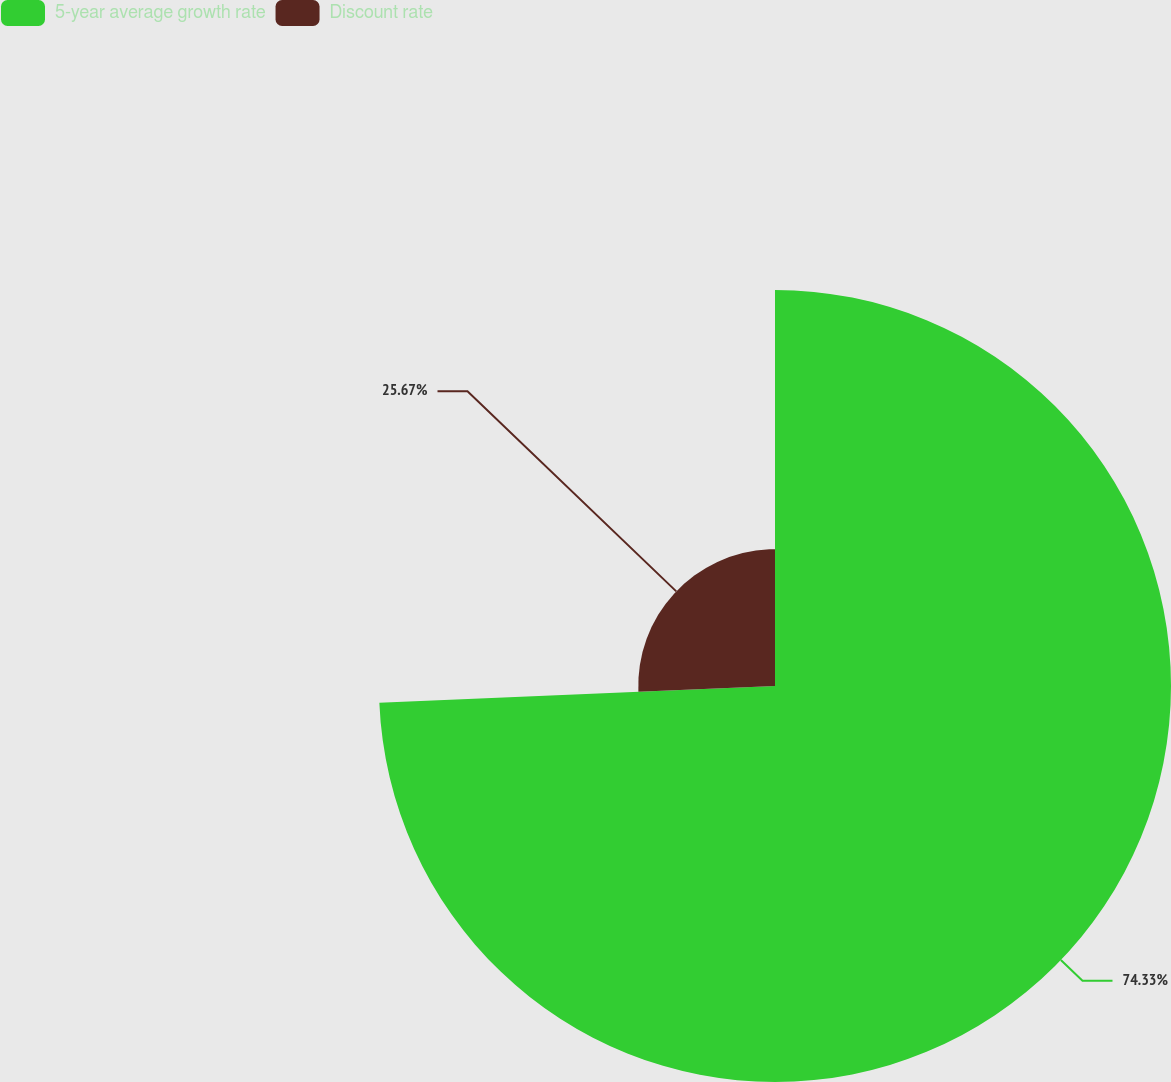Convert chart. <chart><loc_0><loc_0><loc_500><loc_500><pie_chart><fcel>5-year average growth rate<fcel>Discount rate<nl><fcel>74.33%<fcel>25.67%<nl></chart> 